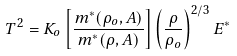<formula> <loc_0><loc_0><loc_500><loc_500>T ^ { 2 } = K _ { o } \left [ \frac { m ^ { * } ( \rho _ { o } , A ) } { m ^ { * } ( \rho , A ) } \right ] \left ( \frac { \rho } { \rho _ { o } } \right ) ^ { 2 / 3 } E ^ { * }</formula> 